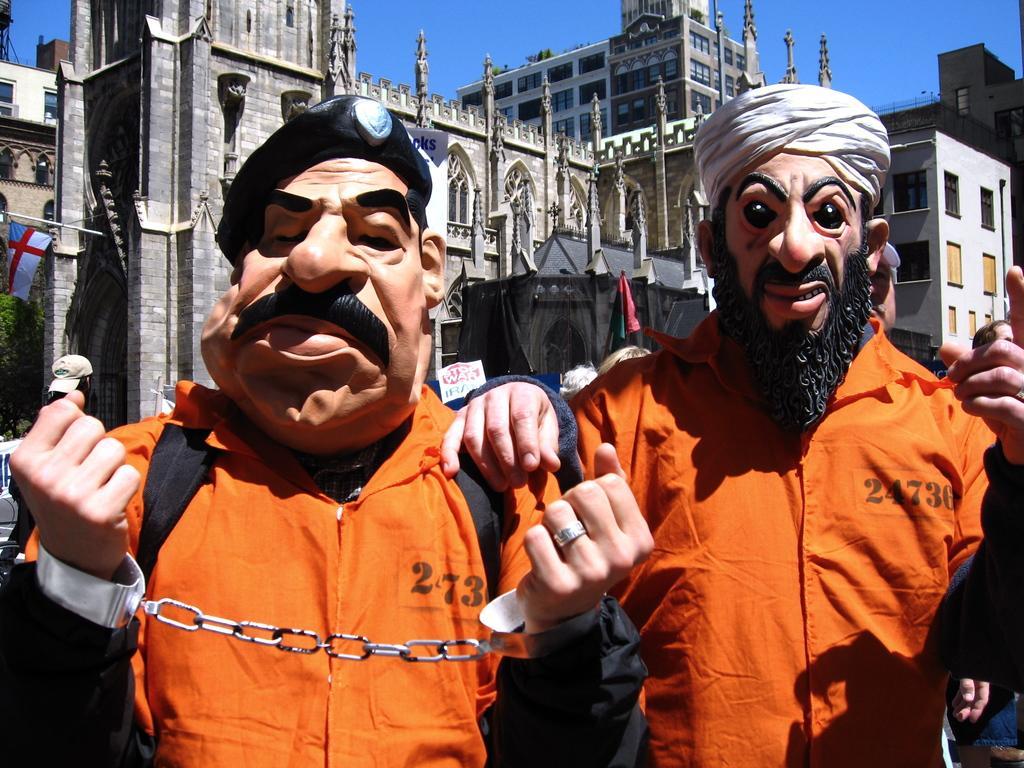Could you give a brief overview of what you see in this image? In this image I can see on the left side a human were handcuffs, orange color coat and a cartoon face. On the right side there is another person did the same thing, in the middle there are buildings, at the top it is the sky. 